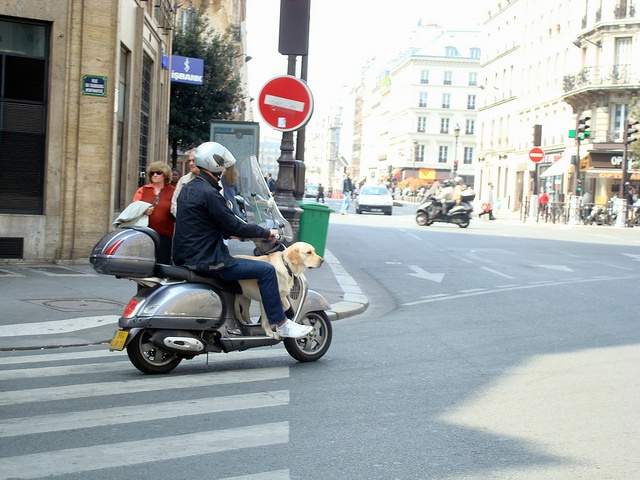Describe the objects in this image and their specific colors. I can see motorcycle in gray, black, darkgray, and lightgray tones, people in gray, black, navy, and white tones, dog in gray, black, darkgray, and beige tones, people in gray, maroon, black, and brown tones, and motorcycle in gray, white, darkgray, and purple tones in this image. 